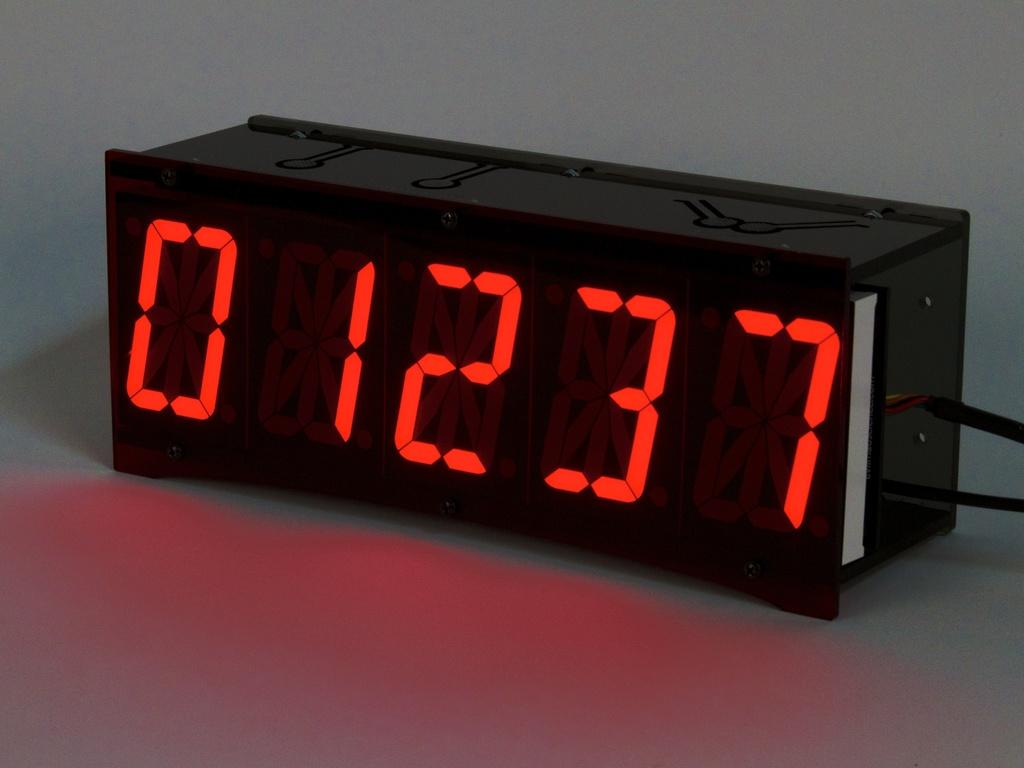Is this an odd or an even number?
Your answer should be compact. Odd. 